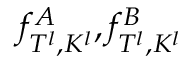Convert formula to latex. <formula><loc_0><loc_0><loc_500><loc_500>f _ { T ^ { l } , K ^ { l } } ^ { A } , f _ { T ^ { l } , K ^ { l } } ^ { B }</formula> 